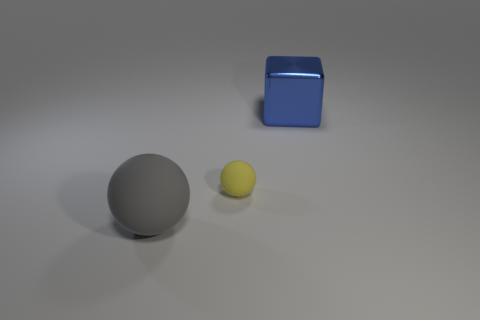Add 3 big things. How many objects exist? 6 Subtract all spheres. How many objects are left? 1 Subtract all gray blocks. Subtract all tiny yellow spheres. How many objects are left? 2 Add 2 spheres. How many spheres are left? 4 Add 1 yellow matte spheres. How many yellow matte spheres exist? 2 Subtract 0 cyan balls. How many objects are left? 3 